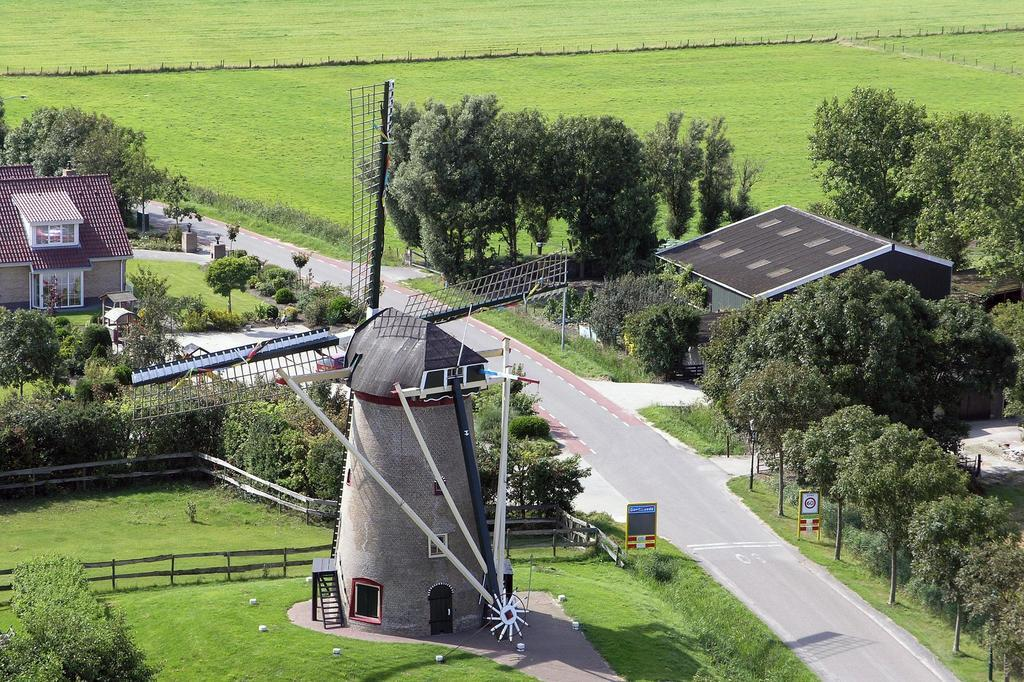What type of natural environment is depicted in the image? There are many trees and plants in the image, indicating a natural environment. What man-made structure can be seen in the image? There is a windmill in the image. What type of terrain is visible at the top of the image? There is a grassy land at the top of the image. How many houses are present in the image? There are two houses in the image. What type of treatment is being administered to the yak in the image? There is no yak present in the image, so no treatment can be administered. What instrument is being played by the person in the image? There is no person or instrument present in the image. 